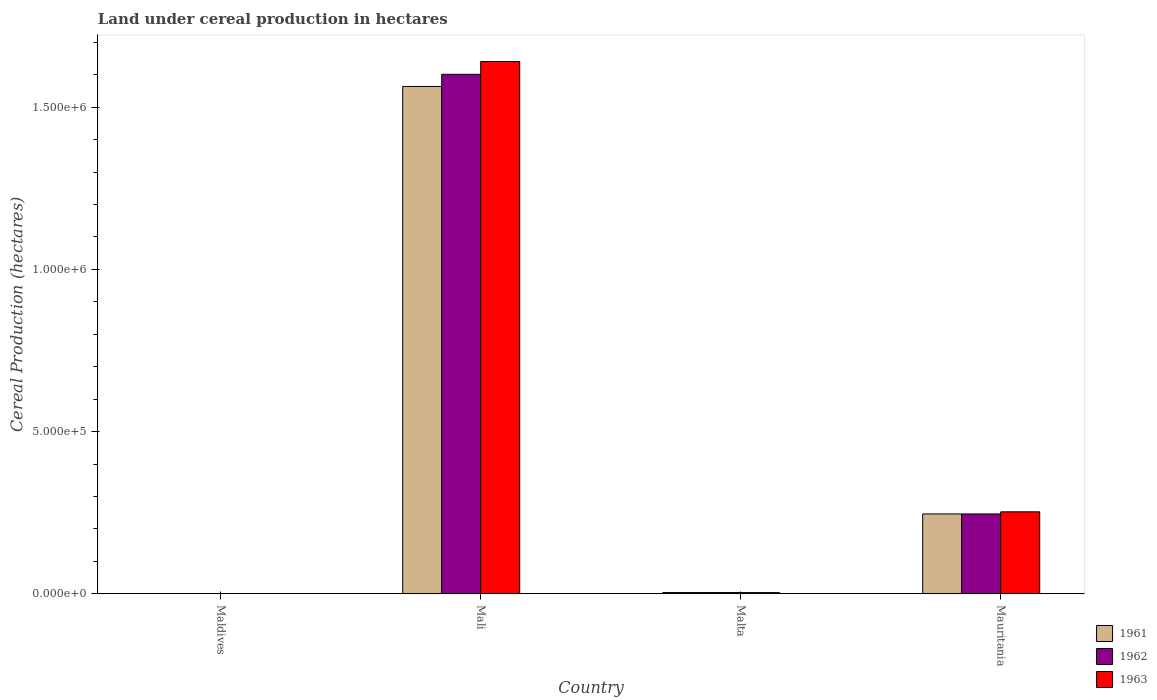Are the number of bars per tick equal to the number of legend labels?
Provide a short and direct response. Yes. Are the number of bars on each tick of the X-axis equal?
Give a very brief answer. Yes. How many bars are there on the 2nd tick from the left?
Offer a very short reply. 3. What is the label of the 4th group of bars from the left?
Provide a succinct answer. Mauritania. What is the land under cereal production in 1961 in Mali?
Provide a succinct answer. 1.56e+06. Across all countries, what is the maximum land under cereal production in 1961?
Give a very brief answer. 1.56e+06. Across all countries, what is the minimum land under cereal production in 1961?
Ensure brevity in your answer.  179. In which country was the land under cereal production in 1962 maximum?
Provide a short and direct response. Mali. In which country was the land under cereal production in 1962 minimum?
Your answer should be compact. Maldives. What is the total land under cereal production in 1962 in the graph?
Offer a terse response. 1.85e+06. What is the difference between the land under cereal production in 1961 in Malta and that in Mauritania?
Your answer should be very brief. -2.42e+05. What is the difference between the land under cereal production in 1961 in Mauritania and the land under cereal production in 1963 in Malta?
Offer a terse response. 2.43e+05. What is the average land under cereal production in 1963 per country?
Provide a short and direct response. 4.74e+05. What is the difference between the land under cereal production of/in 1961 and land under cereal production of/in 1963 in Malta?
Make the answer very short. 136. What is the ratio of the land under cereal production in 1961 in Maldives to that in Malta?
Keep it short and to the point. 0.05. Is the land under cereal production in 1962 in Malta less than that in Mauritania?
Give a very brief answer. Yes. What is the difference between the highest and the second highest land under cereal production in 1963?
Ensure brevity in your answer.  2.49e+05. What is the difference between the highest and the lowest land under cereal production in 1962?
Your answer should be very brief. 1.60e+06. In how many countries, is the land under cereal production in 1962 greater than the average land under cereal production in 1962 taken over all countries?
Offer a terse response. 1. Is the sum of the land under cereal production in 1961 in Mali and Malta greater than the maximum land under cereal production in 1962 across all countries?
Give a very brief answer. No. Are all the bars in the graph horizontal?
Make the answer very short. No. How many countries are there in the graph?
Keep it short and to the point. 4. What is the difference between two consecutive major ticks on the Y-axis?
Keep it short and to the point. 5.00e+05. What is the title of the graph?
Keep it short and to the point. Land under cereal production in hectares. Does "1965" appear as one of the legend labels in the graph?
Provide a short and direct response. No. What is the label or title of the X-axis?
Offer a terse response. Country. What is the label or title of the Y-axis?
Offer a terse response. Cereal Production (hectares). What is the Cereal Production (hectares) of 1961 in Maldives?
Your answer should be very brief. 179. What is the Cereal Production (hectares) of 1962 in Maldives?
Ensure brevity in your answer.  240. What is the Cereal Production (hectares) of 1963 in Maldives?
Your answer should be very brief. 292. What is the Cereal Production (hectares) in 1961 in Mali?
Make the answer very short. 1.56e+06. What is the Cereal Production (hectares) of 1962 in Mali?
Provide a succinct answer. 1.60e+06. What is the Cereal Production (hectares) in 1963 in Mali?
Ensure brevity in your answer.  1.64e+06. What is the Cereal Production (hectares) of 1961 in Malta?
Offer a terse response. 3649. What is the Cereal Production (hectares) of 1962 in Malta?
Offer a terse response. 3699. What is the Cereal Production (hectares) of 1963 in Malta?
Your response must be concise. 3513. What is the Cereal Production (hectares) in 1961 in Mauritania?
Your answer should be compact. 2.46e+05. What is the Cereal Production (hectares) of 1962 in Mauritania?
Your response must be concise. 2.46e+05. What is the Cereal Production (hectares) of 1963 in Mauritania?
Your answer should be very brief. 2.53e+05. Across all countries, what is the maximum Cereal Production (hectares) of 1961?
Your answer should be very brief. 1.56e+06. Across all countries, what is the maximum Cereal Production (hectares) in 1962?
Make the answer very short. 1.60e+06. Across all countries, what is the maximum Cereal Production (hectares) of 1963?
Your answer should be very brief. 1.64e+06. Across all countries, what is the minimum Cereal Production (hectares) of 1961?
Offer a very short reply. 179. Across all countries, what is the minimum Cereal Production (hectares) in 1962?
Your response must be concise. 240. Across all countries, what is the minimum Cereal Production (hectares) of 1963?
Your response must be concise. 292. What is the total Cereal Production (hectares) in 1961 in the graph?
Provide a succinct answer. 1.81e+06. What is the total Cereal Production (hectares) in 1962 in the graph?
Make the answer very short. 1.85e+06. What is the total Cereal Production (hectares) of 1963 in the graph?
Provide a succinct answer. 1.90e+06. What is the difference between the Cereal Production (hectares) of 1961 in Maldives and that in Mali?
Offer a terse response. -1.56e+06. What is the difference between the Cereal Production (hectares) of 1962 in Maldives and that in Mali?
Your response must be concise. -1.60e+06. What is the difference between the Cereal Production (hectares) of 1963 in Maldives and that in Mali?
Your answer should be compact. -1.64e+06. What is the difference between the Cereal Production (hectares) in 1961 in Maldives and that in Malta?
Ensure brevity in your answer.  -3470. What is the difference between the Cereal Production (hectares) in 1962 in Maldives and that in Malta?
Provide a short and direct response. -3459. What is the difference between the Cereal Production (hectares) in 1963 in Maldives and that in Malta?
Offer a very short reply. -3221. What is the difference between the Cereal Production (hectares) of 1961 in Maldives and that in Mauritania?
Offer a terse response. -2.46e+05. What is the difference between the Cereal Production (hectares) of 1962 in Maldives and that in Mauritania?
Provide a short and direct response. -2.46e+05. What is the difference between the Cereal Production (hectares) of 1963 in Maldives and that in Mauritania?
Make the answer very short. -2.52e+05. What is the difference between the Cereal Production (hectares) in 1961 in Mali and that in Malta?
Provide a short and direct response. 1.56e+06. What is the difference between the Cereal Production (hectares) in 1962 in Mali and that in Malta?
Provide a short and direct response. 1.60e+06. What is the difference between the Cereal Production (hectares) of 1963 in Mali and that in Malta?
Keep it short and to the point. 1.64e+06. What is the difference between the Cereal Production (hectares) of 1961 in Mali and that in Mauritania?
Give a very brief answer. 1.32e+06. What is the difference between the Cereal Production (hectares) in 1962 in Mali and that in Mauritania?
Keep it short and to the point. 1.36e+06. What is the difference between the Cereal Production (hectares) of 1963 in Mali and that in Mauritania?
Your response must be concise. 1.39e+06. What is the difference between the Cereal Production (hectares) of 1961 in Malta and that in Mauritania?
Offer a very short reply. -2.42e+05. What is the difference between the Cereal Production (hectares) in 1962 in Malta and that in Mauritania?
Give a very brief answer. -2.42e+05. What is the difference between the Cereal Production (hectares) of 1963 in Malta and that in Mauritania?
Your answer should be compact. -2.49e+05. What is the difference between the Cereal Production (hectares) in 1961 in Maldives and the Cereal Production (hectares) in 1962 in Mali?
Ensure brevity in your answer.  -1.60e+06. What is the difference between the Cereal Production (hectares) in 1961 in Maldives and the Cereal Production (hectares) in 1963 in Mali?
Provide a short and direct response. -1.64e+06. What is the difference between the Cereal Production (hectares) of 1962 in Maldives and the Cereal Production (hectares) of 1963 in Mali?
Your answer should be compact. -1.64e+06. What is the difference between the Cereal Production (hectares) in 1961 in Maldives and the Cereal Production (hectares) in 1962 in Malta?
Your answer should be compact. -3520. What is the difference between the Cereal Production (hectares) of 1961 in Maldives and the Cereal Production (hectares) of 1963 in Malta?
Your response must be concise. -3334. What is the difference between the Cereal Production (hectares) of 1962 in Maldives and the Cereal Production (hectares) of 1963 in Malta?
Offer a terse response. -3273. What is the difference between the Cereal Production (hectares) in 1961 in Maldives and the Cereal Production (hectares) in 1962 in Mauritania?
Your answer should be very brief. -2.46e+05. What is the difference between the Cereal Production (hectares) in 1961 in Maldives and the Cereal Production (hectares) in 1963 in Mauritania?
Offer a very short reply. -2.52e+05. What is the difference between the Cereal Production (hectares) in 1962 in Maldives and the Cereal Production (hectares) in 1963 in Mauritania?
Ensure brevity in your answer.  -2.52e+05. What is the difference between the Cereal Production (hectares) of 1961 in Mali and the Cereal Production (hectares) of 1962 in Malta?
Your answer should be compact. 1.56e+06. What is the difference between the Cereal Production (hectares) of 1961 in Mali and the Cereal Production (hectares) of 1963 in Malta?
Keep it short and to the point. 1.56e+06. What is the difference between the Cereal Production (hectares) in 1962 in Mali and the Cereal Production (hectares) in 1963 in Malta?
Your answer should be very brief. 1.60e+06. What is the difference between the Cereal Production (hectares) in 1961 in Mali and the Cereal Production (hectares) in 1962 in Mauritania?
Keep it short and to the point. 1.32e+06. What is the difference between the Cereal Production (hectares) in 1961 in Mali and the Cereal Production (hectares) in 1963 in Mauritania?
Keep it short and to the point. 1.31e+06. What is the difference between the Cereal Production (hectares) of 1962 in Mali and the Cereal Production (hectares) of 1963 in Mauritania?
Keep it short and to the point. 1.35e+06. What is the difference between the Cereal Production (hectares) of 1961 in Malta and the Cereal Production (hectares) of 1962 in Mauritania?
Ensure brevity in your answer.  -2.42e+05. What is the difference between the Cereal Production (hectares) in 1961 in Malta and the Cereal Production (hectares) in 1963 in Mauritania?
Make the answer very short. -2.49e+05. What is the difference between the Cereal Production (hectares) in 1962 in Malta and the Cereal Production (hectares) in 1963 in Mauritania?
Your response must be concise. -2.49e+05. What is the average Cereal Production (hectares) of 1961 per country?
Provide a short and direct response. 4.53e+05. What is the average Cereal Production (hectares) of 1962 per country?
Offer a terse response. 4.63e+05. What is the average Cereal Production (hectares) in 1963 per country?
Offer a terse response. 4.74e+05. What is the difference between the Cereal Production (hectares) in 1961 and Cereal Production (hectares) in 1962 in Maldives?
Keep it short and to the point. -61. What is the difference between the Cereal Production (hectares) in 1961 and Cereal Production (hectares) in 1963 in Maldives?
Provide a short and direct response. -113. What is the difference between the Cereal Production (hectares) of 1962 and Cereal Production (hectares) of 1963 in Maldives?
Your answer should be very brief. -52. What is the difference between the Cereal Production (hectares) of 1961 and Cereal Production (hectares) of 1962 in Mali?
Offer a terse response. -3.75e+04. What is the difference between the Cereal Production (hectares) of 1961 and Cereal Production (hectares) of 1963 in Mali?
Provide a short and direct response. -7.71e+04. What is the difference between the Cereal Production (hectares) in 1962 and Cereal Production (hectares) in 1963 in Mali?
Ensure brevity in your answer.  -3.96e+04. What is the difference between the Cereal Production (hectares) in 1961 and Cereal Production (hectares) in 1963 in Malta?
Your answer should be compact. 136. What is the difference between the Cereal Production (hectares) of 1962 and Cereal Production (hectares) of 1963 in Malta?
Offer a terse response. 186. What is the difference between the Cereal Production (hectares) in 1961 and Cereal Production (hectares) in 1962 in Mauritania?
Your response must be concise. 0. What is the difference between the Cereal Production (hectares) of 1961 and Cereal Production (hectares) of 1963 in Mauritania?
Your answer should be very brief. -6550. What is the difference between the Cereal Production (hectares) in 1962 and Cereal Production (hectares) in 1963 in Mauritania?
Your response must be concise. -6550. What is the ratio of the Cereal Production (hectares) of 1961 in Maldives to that in Mali?
Keep it short and to the point. 0. What is the ratio of the Cereal Production (hectares) in 1962 in Maldives to that in Mali?
Provide a succinct answer. 0. What is the ratio of the Cereal Production (hectares) of 1963 in Maldives to that in Mali?
Your response must be concise. 0. What is the ratio of the Cereal Production (hectares) of 1961 in Maldives to that in Malta?
Your answer should be compact. 0.05. What is the ratio of the Cereal Production (hectares) of 1962 in Maldives to that in Malta?
Your answer should be compact. 0.06. What is the ratio of the Cereal Production (hectares) of 1963 in Maldives to that in Malta?
Provide a short and direct response. 0.08. What is the ratio of the Cereal Production (hectares) of 1961 in Maldives to that in Mauritania?
Your answer should be compact. 0. What is the ratio of the Cereal Production (hectares) of 1963 in Maldives to that in Mauritania?
Offer a terse response. 0. What is the ratio of the Cereal Production (hectares) of 1961 in Mali to that in Malta?
Ensure brevity in your answer.  428.61. What is the ratio of the Cereal Production (hectares) in 1962 in Mali to that in Malta?
Provide a succinct answer. 432.95. What is the ratio of the Cereal Production (hectares) in 1963 in Mali to that in Malta?
Your answer should be compact. 467.14. What is the ratio of the Cereal Production (hectares) of 1961 in Mali to that in Mauritania?
Ensure brevity in your answer.  6.36. What is the ratio of the Cereal Production (hectares) in 1962 in Mali to that in Mauritania?
Offer a very short reply. 6.51. What is the ratio of the Cereal Production (hectares) in 1963 in Mali to that in Mauritania?
Make the answer very short. 6.5. What is the ratio of the Cereal Production (hectares) in 1961 in Malta to that in Mauritania?
Ensure brevity in your answer.  0.01. What is the ratio of the Cereal Production (hectares) of 1962 in Malta to that in Mauritania?
Your answer should be compact. 0.01. What is the ratio of the Cereal Production (hectares) of 1963 in Malta to that in Mauritania?
Keep it short and to the point. 0.01. What is the difference between the highest and the second highest Cereal Production (hectares) of 1961?
Your response must be concise. 1.32e+06. What is the difference between the highest and the second highest Cereal Production (hectares) in 1962?
Keep it short and to the point. 1.36e+06. What is the difference between the highest and the second highest Cereal Production (hectares) of 1963?
Offer a very short reply. 1.39e+06. What is the difference between the highest and the lowest Cereal Production (hectares) of 1961?
Keep it short and to the point. 1.56e+06. What is the difference between the highest and the lowest Cereal Production (hectares) in 1962?
Your answer should be very brief. 1.60e+06. What is the difference between the highest and the lowest Cereal Production (hectares) in 1963?
Offer a terse response. 1.64e+06. 